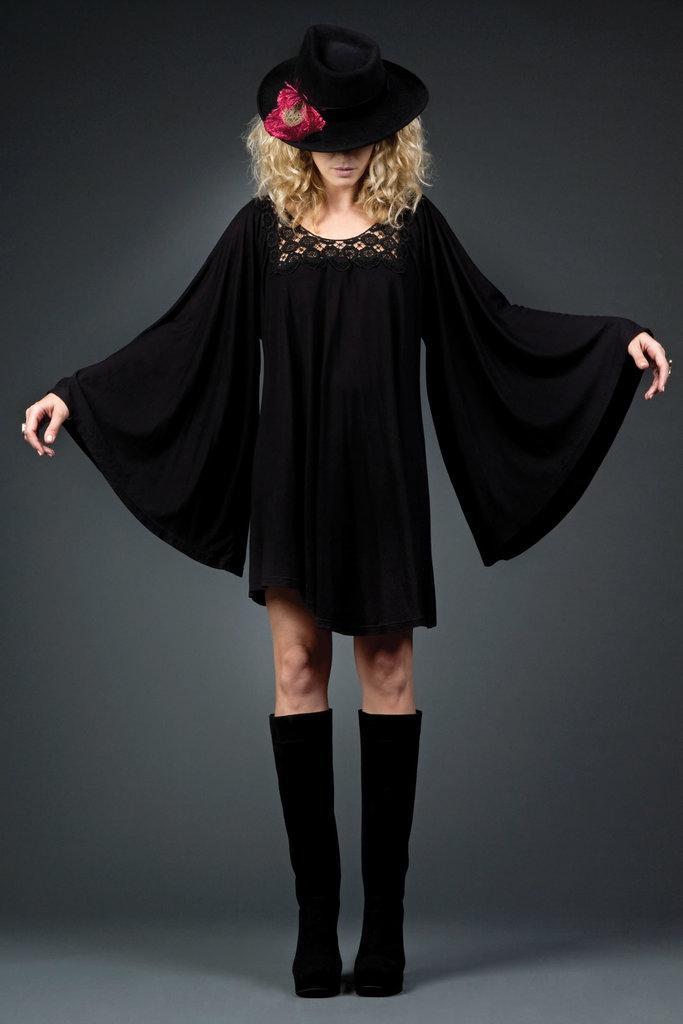How would you summarize this image in a sentence or two? In this image I can see a woman is standing. I can see she is wearing a black colour hat, black dress and black shoes. I can also see a red colour thing on the hat. 